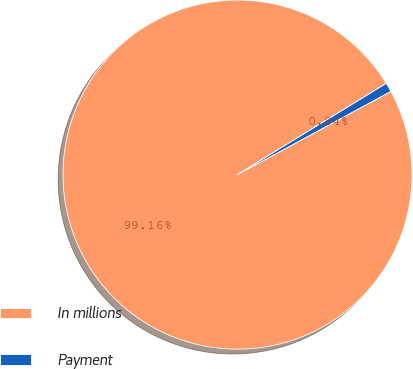<chart> <loc_0><loc_0><loc_500><loc_500><pie_chart><fcel>In millions<fcel>Payment<nl><fcel>99.16%<fcel>0.84%<nl></chart> 